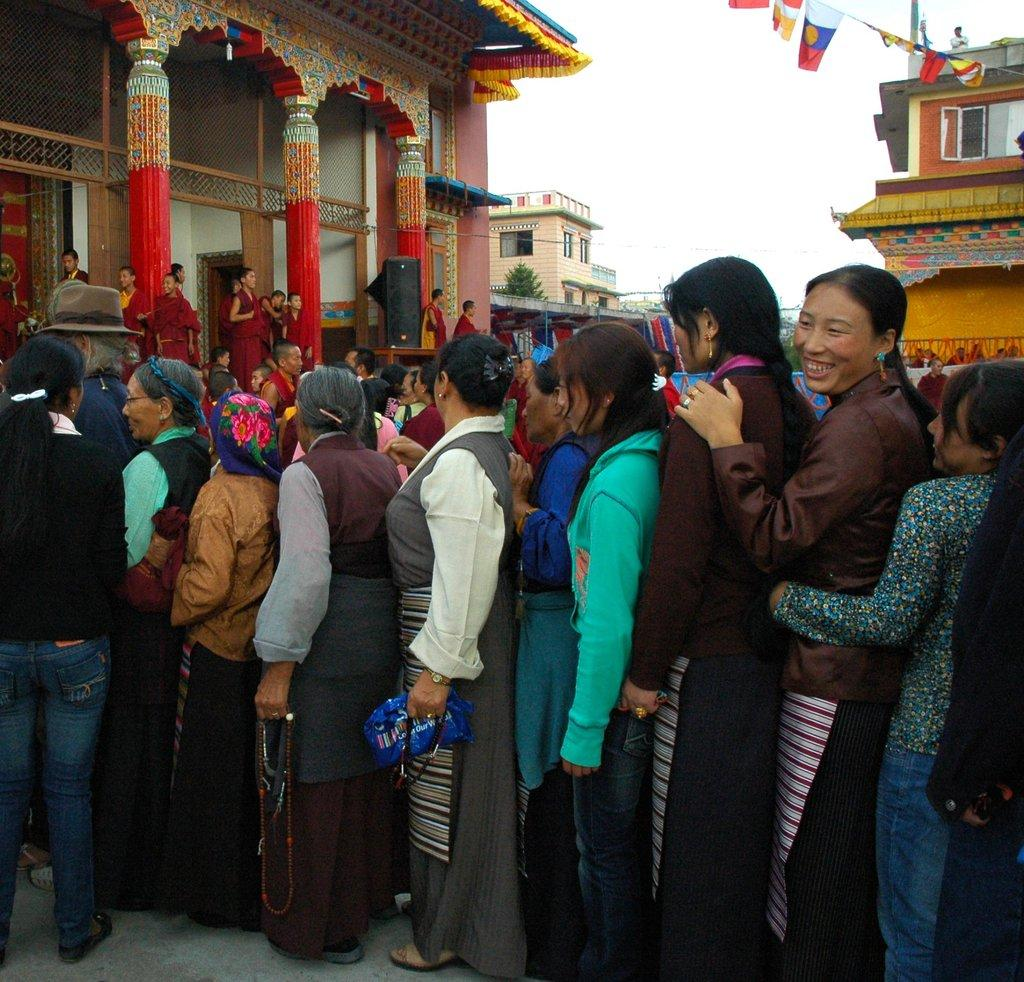What is the main subject of the image? The main subject of the image is a crowd of people. Where are the people located in the image? The people are standing on the ground. What can be seen in the background of the image? In the background of the image, there are buildings, trees, flags, speakers, and the sky. What type of soda is being served to the secretary in the image? There is no secretary or soda present in the image; it features a crowd of people standing on the ground with various elements in the background. 